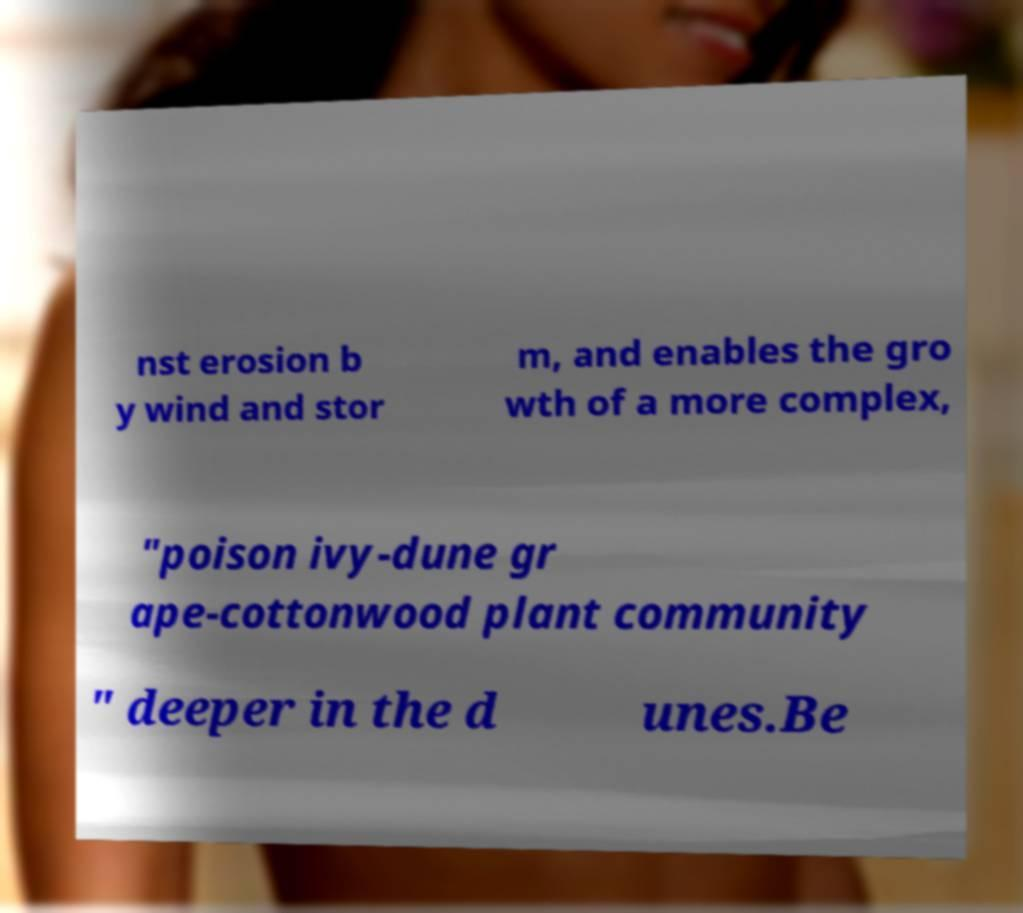Please identify and transcribe the text found in this image. nst erosion b y wind and stor m, and enables the gro wth of a more complex, "poison ivy-dune gr ape-cottonwood plant community " deeper in the d unes.Be 